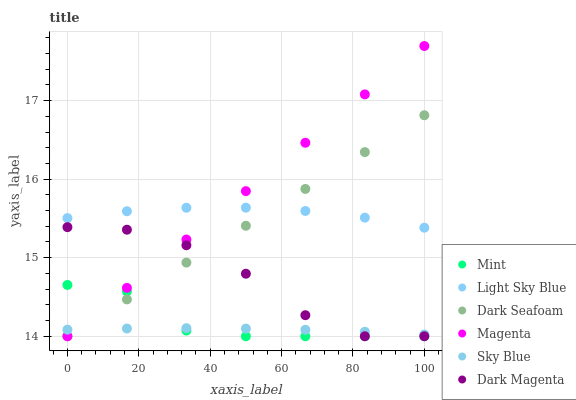Does Sky Blue have the minimum area under the curve?
Answer yes or no. Yes. Does Magenta have the maximum area under the curve?
Answer yes or no. Yes. Does Dark Seafoam have the minimum area under the curve?
Answer yes or no. No. Does Dark Seafoam have the maximum area under the curve?
Answer yes or no. No. Is Magenta the smoothest?
Answer yes or no. Yes. Is Dark Magenta the roughest?
Answer yes or no. Yes. Is Dark Seafoam the smoothest?
Answer yes or no. No. Is Dark Seafoam the roughest?
Answer yes or no. No. Does Dark Magenta have the lowest value?
Answer yes or no. Yes. Does Light Sky Blue have the lowest value?
Answer yes or no. No. Does Magenta have the highest value?
Answer yes or no. Yes. Does Dark Seafoam have the highest value?
Answer yes or no. No. Is Mint less than Light Sky Blue?
Answer yes or no. Yes. Is Light Sky Blue greater than Dark Magenta?
Answer yes or no. Yes. Does Mint intersect Dark Magenta?
Answer yes or no. Yes. Is Mint less than Dark Magenta?
Answer yes or no. No. Is Mint greater than Dark Magenta?
Answer yes or no. No. Does Mint intersect Light Sky Blue?
Answer yes or no. No. 